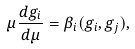Convert formula to latex. <formula><loc_0><loc_0><loc_500><loc_500>\mu \frac { d g _ { i } } { d \mu } = \beta _ { i } ( g _ { i } , g _ { j } ) ,</formula> 